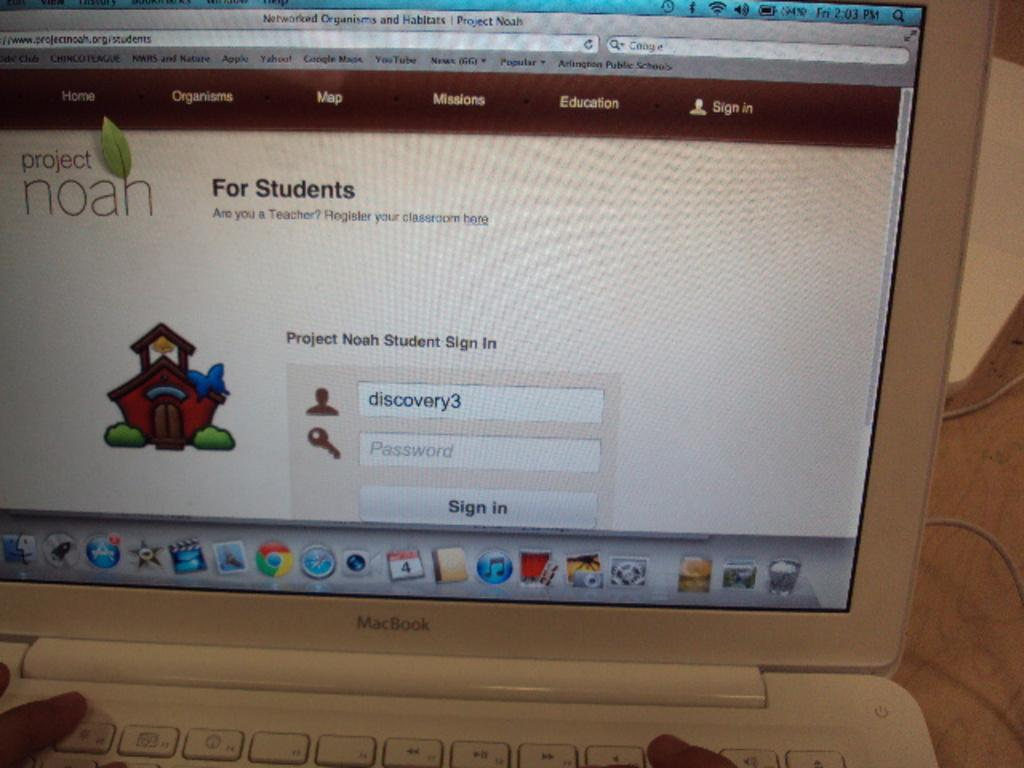Provide a one-sentence caption for the provided image. A laptop computer displays the sign in page for a site named Project Noah. 